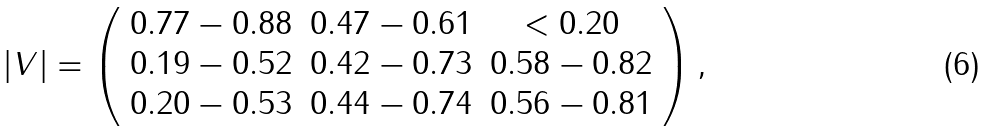<formula> <loc_0><loc_0><loc_500><loc_500>| V | = \left ( \begin{array} { c c c } 0 . 7 7 - 0 . 8 8 & 0 . 4 7 - 0 . 6 1 & < 0 . 2 0 \\ 0 . 1 9 - 0 . 5 2 & 0 . 4 2 - 0 . 7 3 & 0 . 5 8 - 0 . 8 2 \\ 0 . 2 0 - 0 . 5 3 & 0 . 4 4 - 0 . 7 4 & 0 . 5 6 - 0 . 8 1 \\ \end{array} \right ) ,</formula> 